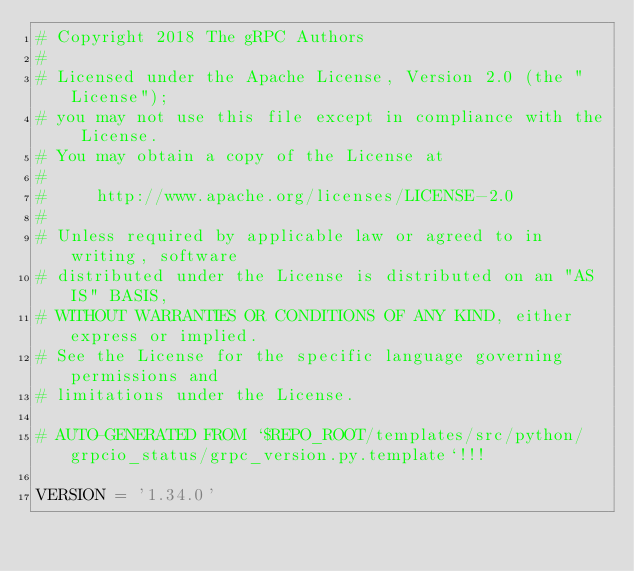Convert code to text. <code><loc_0><loc_0><loc_500><loc_500><_Python_># Copyright 2018 The gRPC Authors
#
# Licensed under the Apache License, Version 2.0 (the "License");
# you may not use this file except in compliance with the License.
# You may obtain a copy of the License at
#
#     http://www.apache.org/licenses/LICENSE-2.0
#
# Unless required by applicable law or agreed to in writing, software
# distributed under the License is distributed on an "AS IS" BASIS,
# WITHOUT WARRANTIES OR CONDITIONS OF ANY KIND, either express or implied.
# See the License for the specific language governing permissions and
# limitations under the License.

# AUTO-GENERATED FROM `$REPO_ROOT/templates/src/python/grpcio_status/grpc_version.py.template`!!!

VERSION = '1.34.0'
</code> 